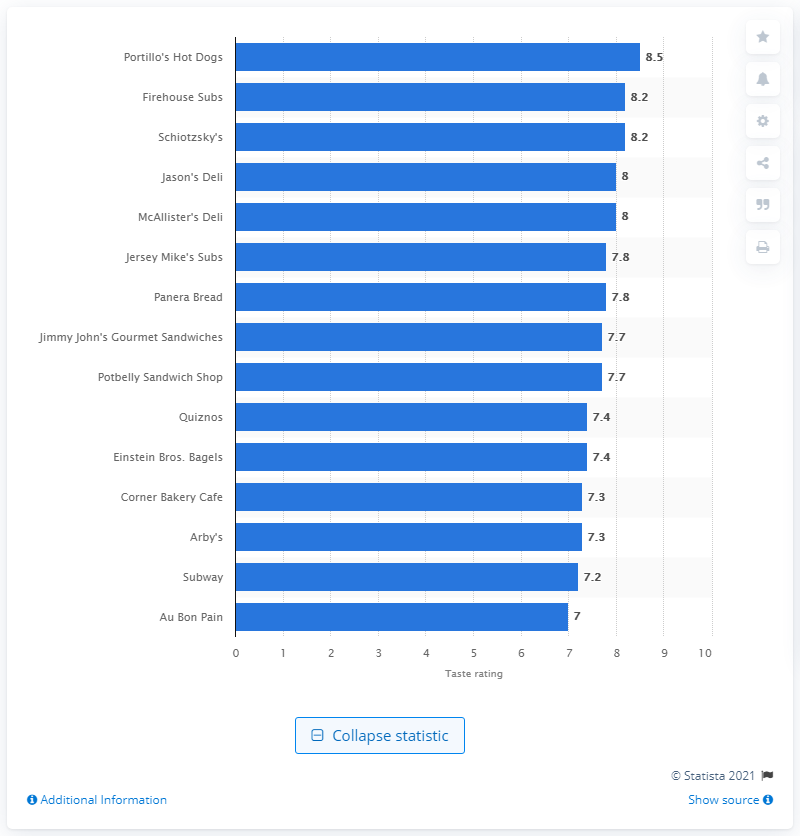Indicate a few pertinent items in this graphic. Schiotzsky's taste rating was 8.2. 